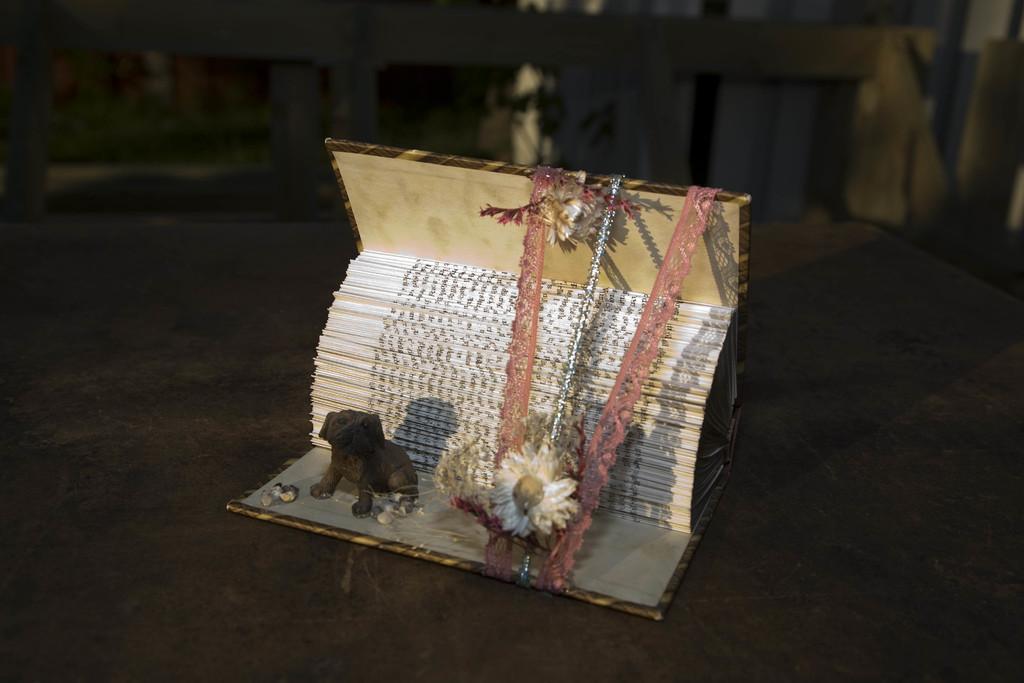How would you summarize this image in a sentence or two? In this picture we can see a toy, flower, cloth pieces, book on a surface and in the background we can see the grass, plant and some objects. 